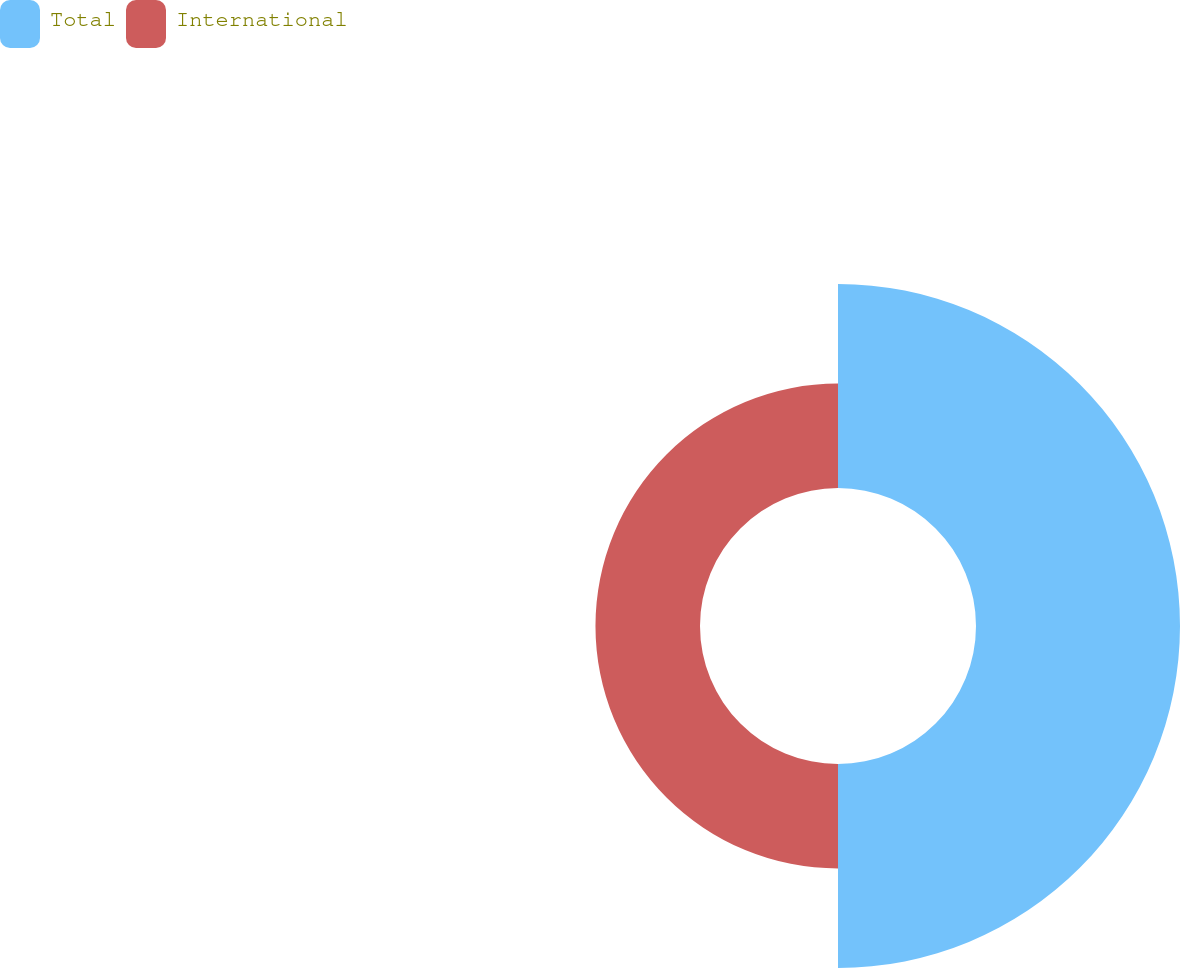Convert chart. <chart><loc_0><loc_0><loc_500><loc_500><pie_chart><fcel>Total<fcel>International<nl><fcel>66.12%<fcel>33.88%<nl></chart> 